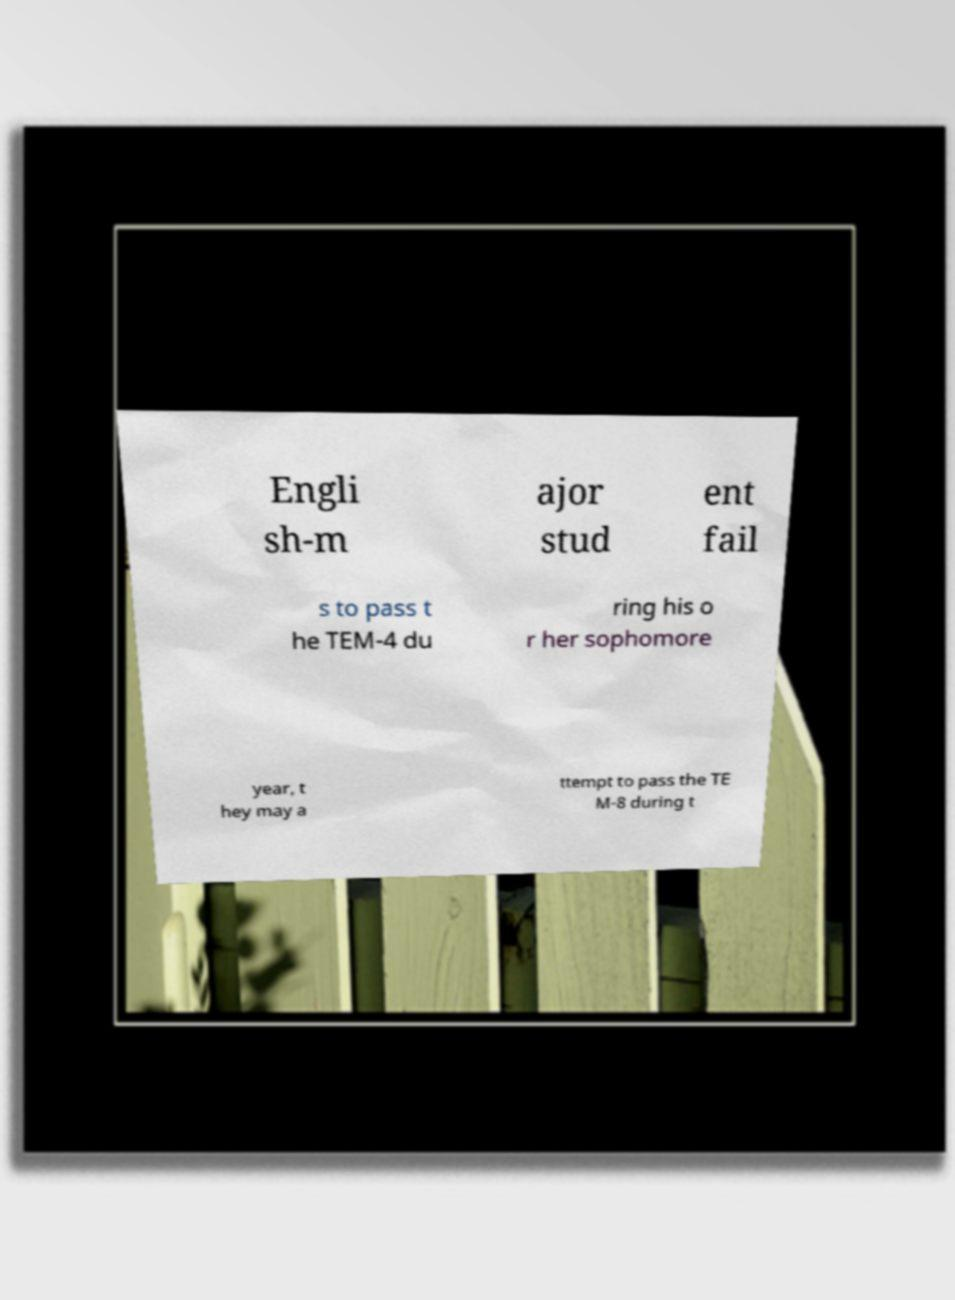Can you accurately transcribe the text from the provided image for me? Engli sh-m ajor stud ent fail s to pass t he TEM-4 du ring his o r her sophomore year, t hey may a ttempt to pass the TE M-8 during t 